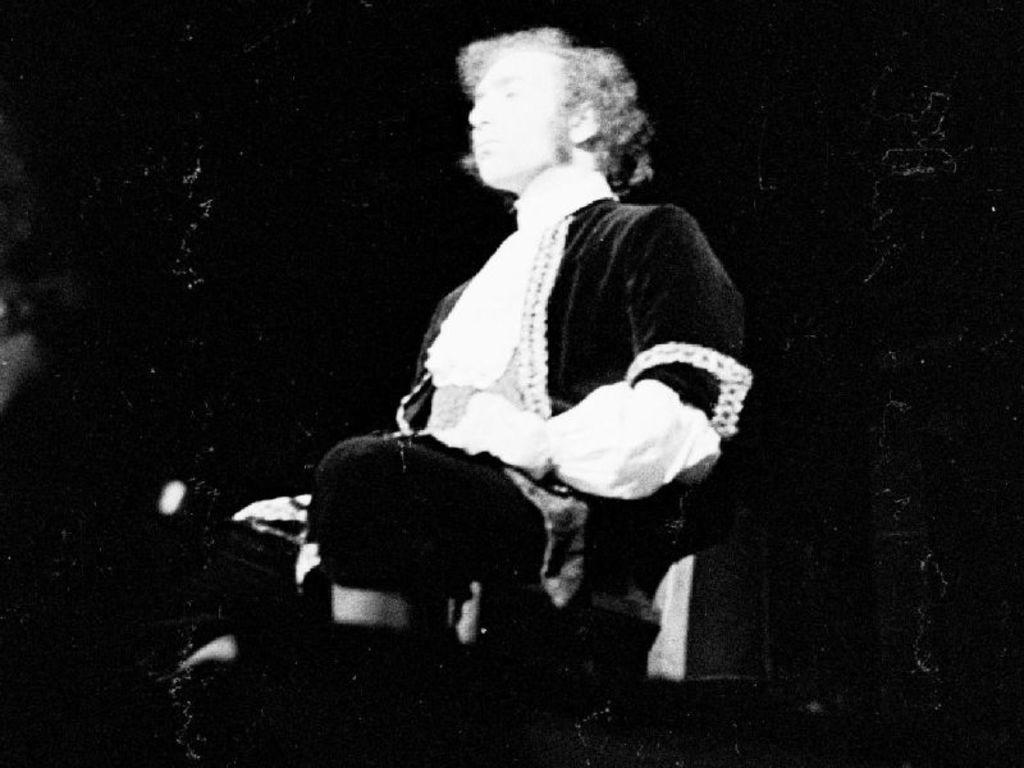Could you give a brief overview of what you see in this image? There is a person sitting on chair. 